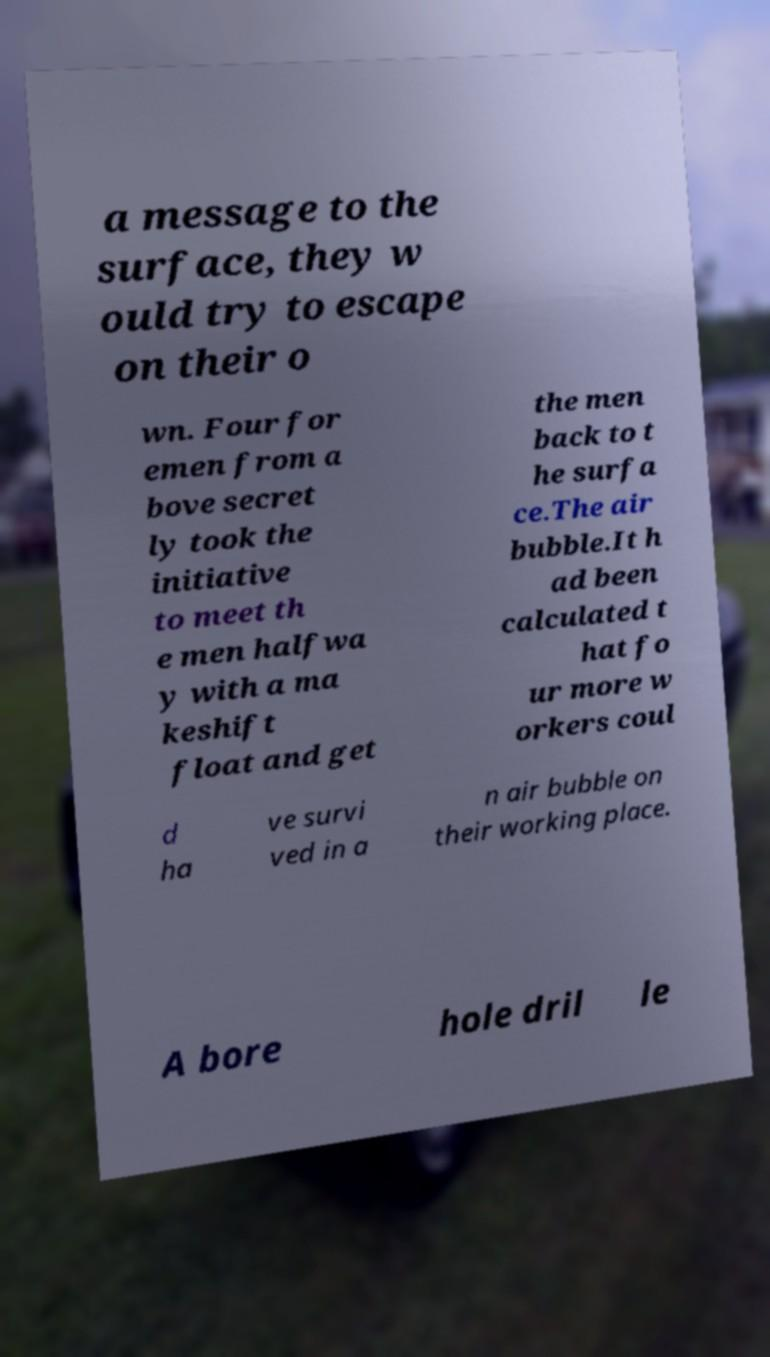For documentation purposes, I need the text within this image transcribed. Could you provide that? a message to the surface, they w ould try to escape on their o wn. Four for emen from a bove secret ly took the initiative to meet th e men halfwa y with a ma keshift float and get the men back to t he surfa ce.The air bubble.It h ad been calculated t hat fo ur more w orkers coul d ha ve survi ved in a n air bubble on their working place. A bore hole dril le 